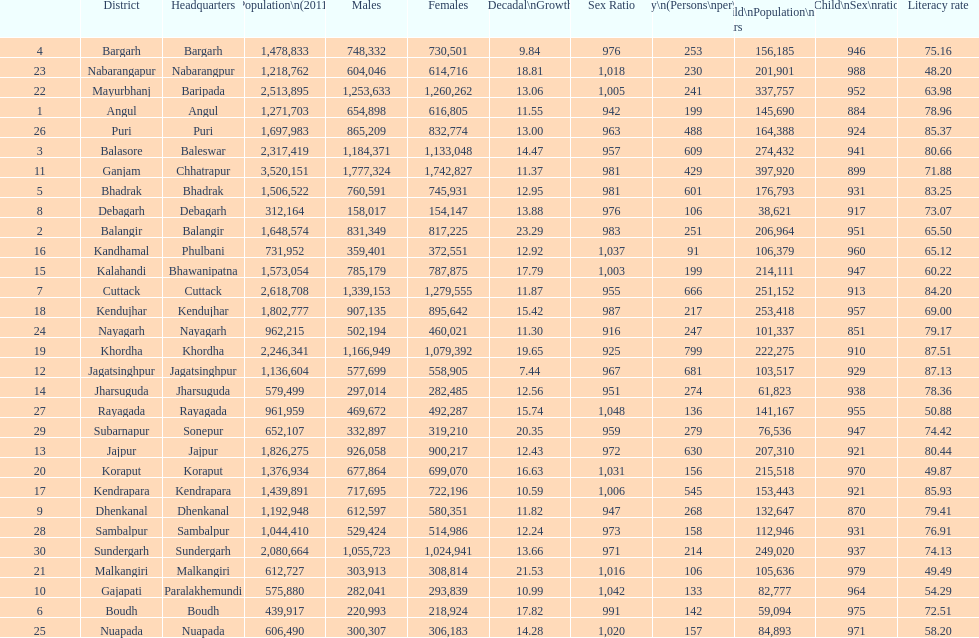From 2001-2011, which district had the smallest population expansion? Jagatsinghpur. 